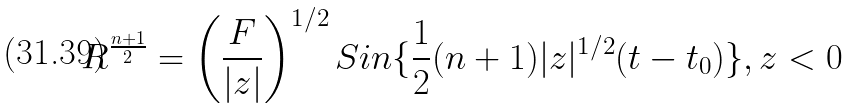<formula> <loc_0><loc_0><loc_500><loc_500>R ^ { \frac { n + 1 } { 2 } } = \left ( \frac { F } { | z | } \right ) ^ { 1 / 2 } S i n \{ \frac { 1 } { 2 } ( n + 1 ) | z | ^ { 1 / 2 } ( t - t _ { 0 } ) \} , z < 0</formula> 